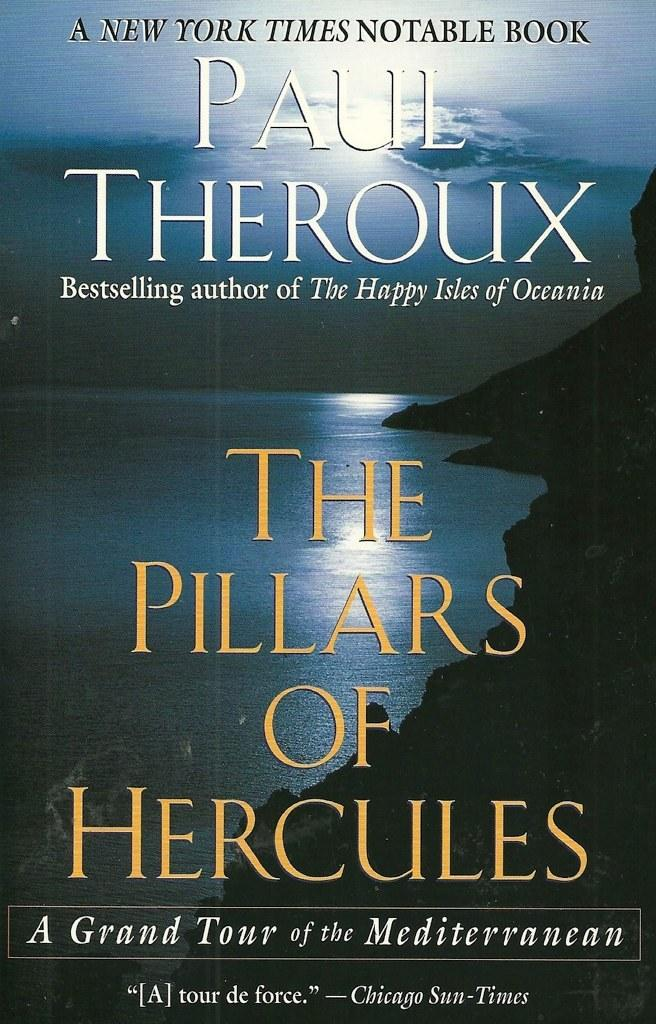<image>
Offer a succinct explanation of the picture presented. The cover for a Paul Theroux novel shows a body of water and some mountains. 